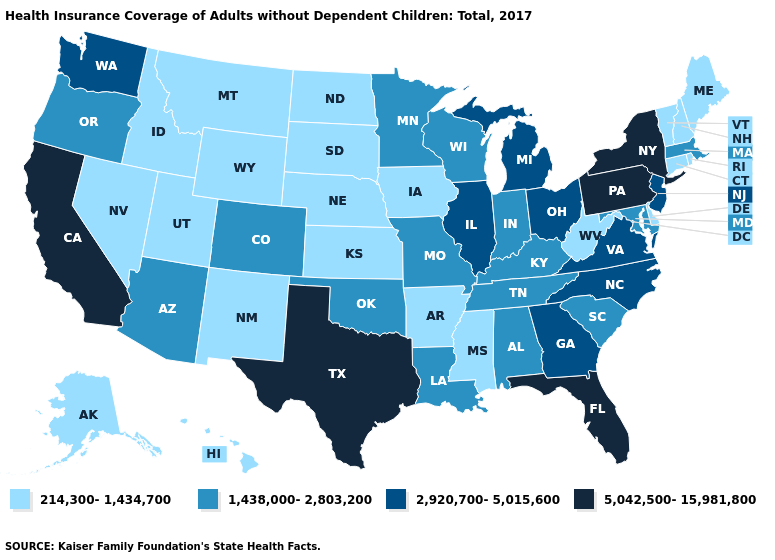Which states have the highest value in the USA?
Keep it brief. California, Florida, New York, Pennsylvania, Texas. What is the lowest value in states that border Wyoming?
Give a very brief answer. 214,300-1,434,700. What is the value of Pennsylvania?
Quick response, please. 5,042,500-15,981,800. Which states have the highest value in the USA?
Answer briefly. California, Florida, New York, Pennsylvania, Texas. Name the states that have a value in the range 214,300-1,434,700?
Be succinct. Alaska, Arkansas, Connecticut, Delaware, Hawaii, Idaho, Iowa, Kansas, Maine, Mississippi, Montana, Nebraska, Nevada, New Hampshire, New Mexico, North Dakota, Rhode Island, South Dakota, Utah, Vermont, West Virginia, Wyoming. What is the value of Louisiana?
Keep it brief. 1,438,000-2,803,200. Among the states that border Alabama , does Georgia have the lowest value?
Be succinct. No. What is the value of Massachusetts?
Give a very brief answer. 1,438,000-2,803,200. Name the states that have a value in the range 5,042,500-15,981,800?
Short answer required. California, Florida, New York, Pennsylvania, Texas. What is the highest value in the South ?
Quick response, please. 5,042,500-15,981,800. Which states have the lowest value in the USA?
Answer briefly. Alaska, Arkansas, Connecticut, Delaware, Hawaii, Idaho, Iowa, Kansas, Maine, Mississippi, Montana, Nebraska, Nevada, New Hampshire, New Mexico, North Dakota, Rhode Island, South Dakota, Utah, Vermont, West Virginia, Wyoming. What is the highest value in the USA?
Concise answer only. 5,042,500-15,981,800. Which states have the highest value in the USA?
Concise answer only. California, Florida, New York, Pennsylvania, Texas. Among the states that border Mississippi , which have the lowest value?
Write a very short answer. Arkansas. Does Texas have the highest value in the South?
Quick response, please. Yes. 